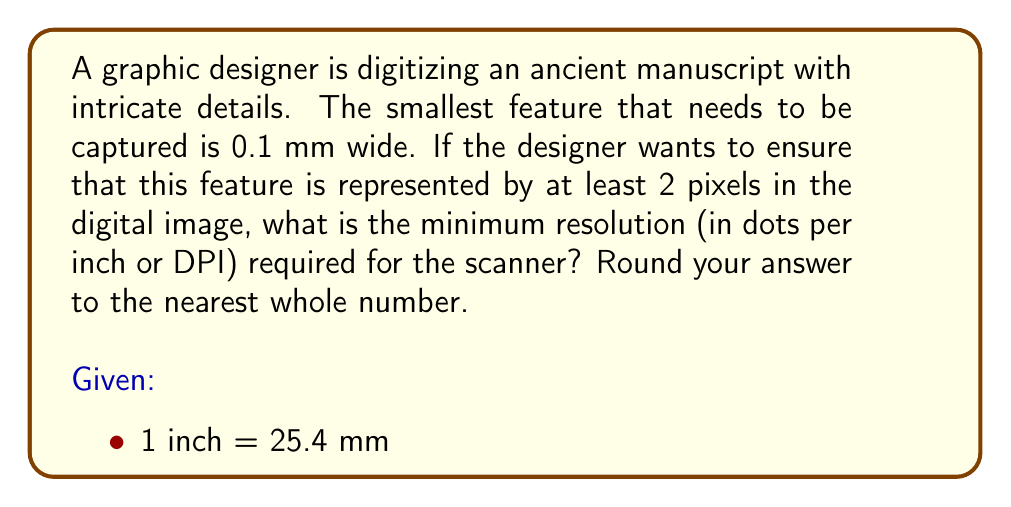Could you help me with this problem? To solve this problem, we need to follow these steps:

1. Determine the number of pixels per mm required:
   - The smallest feature is 0.1 mm
   - We want at least 2 pixels to represent this feature
   - So, we need: $\frac{2 \text{ pixels}}{0.1 \text{ mm}} = 20 \text{ pixels/mm}$

2. Convert pixels/mm to pixels/inch:
   - We know that 1 inch = 25.4 mm
   - So, pixels/inch = pixels/mm * 25.4
   - $20 \text{ pixels/mm} * 25.4 \text{ mm/inch} = 508 \text{ pixels/inch}$

3. The resolution in DPI is equivalent to pixels/inch, so the minimum required resolution is 508 DPI.

4. Rounding to the nearest whole number:
   $\text{round}(508) = 508 \text{ DPI}$

Therefore, the minimum resolution required for the scanner is 508 DPI.
Answer: 508 DPI 